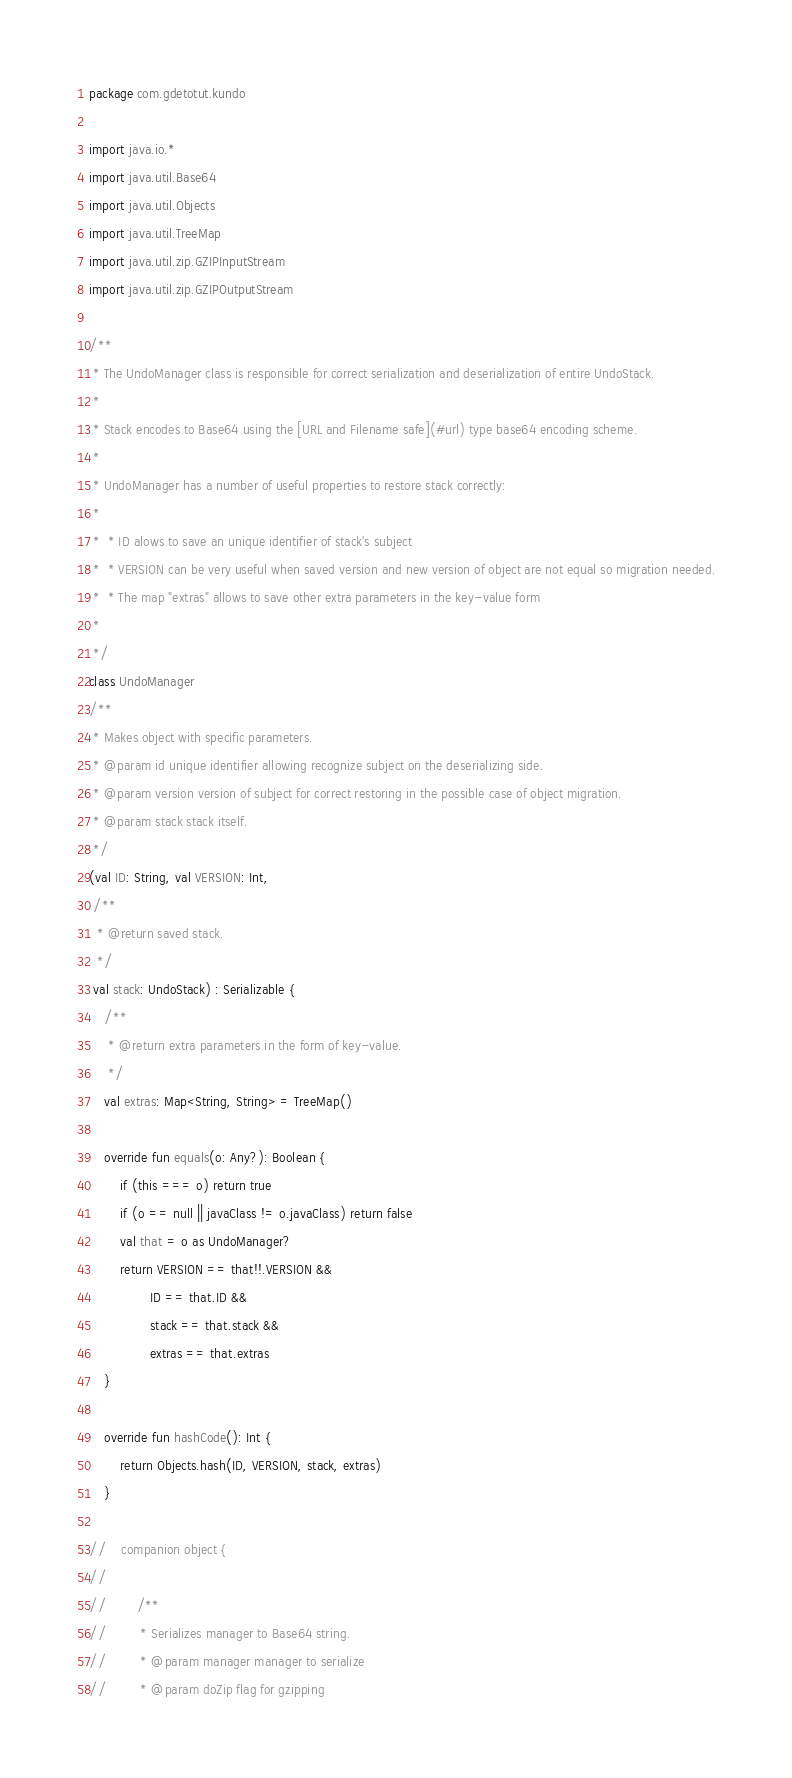Convert code to text. <code><loc_0><loc_0><loc_500><loc_500><_Kotlin_>package com.gdetotut.kundo

import java.io.*
import java.util.Base64
import java.util.Objects
import java.util.TreeMap
import java.util.zip.GZIPInputStream
import java.util.zip.GZIPOutputStream

/**
 * The UndoManager class is responsible for correct serialization and deserialization of entire UndoStack.
 *
 * Stack encodes to Base64 using the [URL and Filename safe](#url) type base64 encoding scheme.
 *
 * UndoManager has a number of useful properties to restore stack correctly:
 *
 *  * ID alows to save an unique identifier of stack's subject
 *  * VERSION can be very useful when saved version and new version of object are not equal so migration needed.
 *  * The map "extras" allows to save other extra parameters in the key-value form
 *
 */
class UndoManager
/**
 * Makes object with specific parameters.
 * @param id unique identifier allowing recognize subject on the deserializing side.
 * @param version version of subject for correct restoring in the possible case of object migration.
 * @param stack stack itself.
 */
(val ID: String, val VERSION: Int,
 /**
  * @return saved stack.
  */
 val stack: UndoStack) : Serializable {
    /**
     * @return extra parameters in the form of key-value.
     */
    val extras: Map<String, String> = TreeMap()

    override fun equals(o: Any?): Boolean {
        if (this === o) return true
        if (o == null || javaClass != o.javaClass) return false
        val that = o as UndoManager?
        return VERSION == that!!.VERSION &&
                ID == that.ID &&
                stack == that.stack &&
                extras == that.extras
    }

    override fun hashCode(): Int {
        return Objects.hash(ID, VERSION, stack, extras)
    }

//    companion object {
//
//        /**
//         * Serializes manager to Base64 string.
//         * @param manager manager to serialize
//         * @param doZip flag for gzipping</code> 